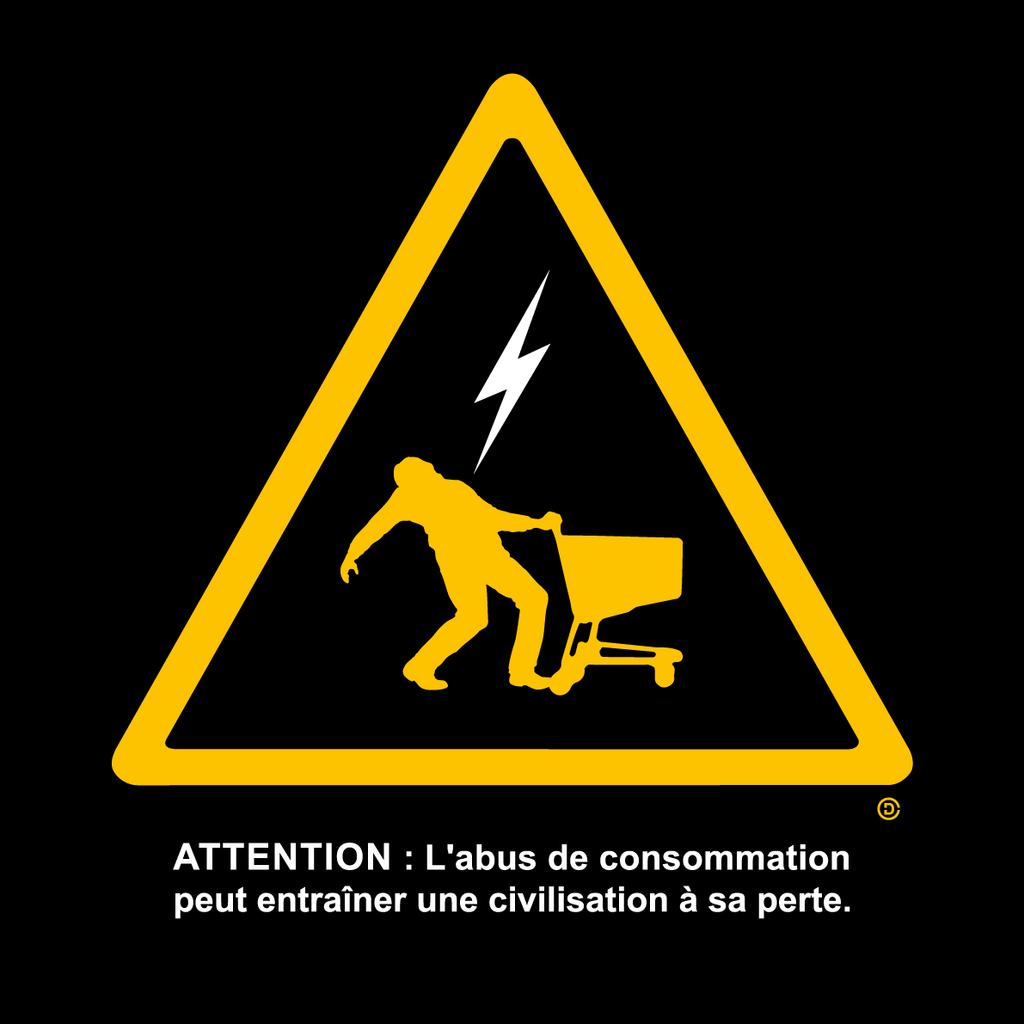Provide a one-sentence caption for the provided image. A sign showing a person being shocked that says Attention. 